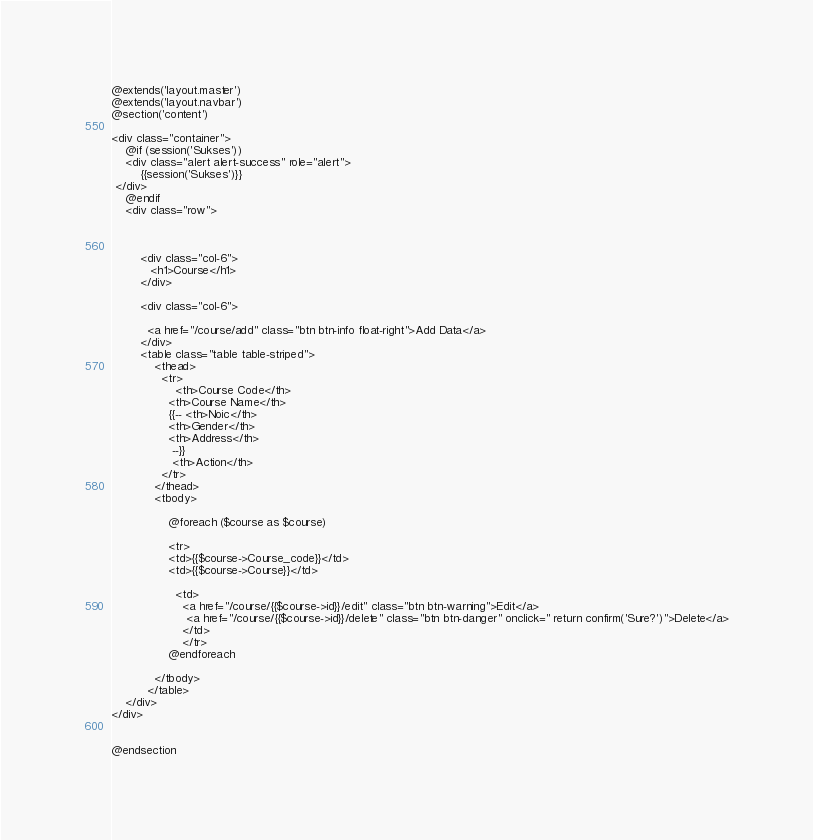<code> <loc_0><loc_0><loc_500><loc_500><_PHP_>@extends('layout.master')
@extends('layout.navbar')
@section('content')

<div class="container">
    @if (session('Sukses'))
    <div class="alert alert-success" role="alert">
        {{session('Sukses')}}
 </div>
    @endif
    <div class="row">
       
         
        
        <div class="col-6">
           <h1>Course</h1>
        </div>
        
        <div class="col-6">
     
          <a href="/course/add" class="btn btn-info float-right">Add Data</a>
        </div>
        <table class="table table-striped">
            <thead>
              <tr>
                  <th>Course Code</th>
                <th>Course Name</th>
                {{-- <th>Noic</th>
                <th>Gender</th>
                <th>Address</th>
                 --}}
                 <th>Action</th>
              </tr>
            </thead>
            <tbody>
               
                @foreach ($course as $course)
        
                <tr>
                <td>{{$course->Course_code}}</td>
                <td>{{$course->Course}}</td>
              
                  <td>
                    <a href="/course/{{$course->id}}/edit" class="btn btn-warning">Edit</a>
                     <a href="/course/{{$course->id}}/delete" class="btn btn-danger" onclick=" return confirm('Sure?')">Delete</a>
                    </td>
                    </tr>
                @endforeach
              
            </tbody>
          </table>
    </div>
</div>

    
@endsection
</code> 